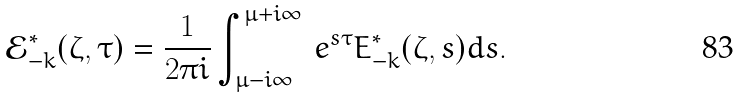<formula> <loc_0><loc_0><loc_500><loc_500>\mathcal { E } _ { - k } ^ { * } ( \zeta , \tau ) = \frac { 1 } { 2 \pi i } \int _ { \mu - i \infty } ^ { \mu + i \infty } \, e ^ { s \tau } E _ { - k } ^ { * } ( \zeta , s ) d s .</formula> 